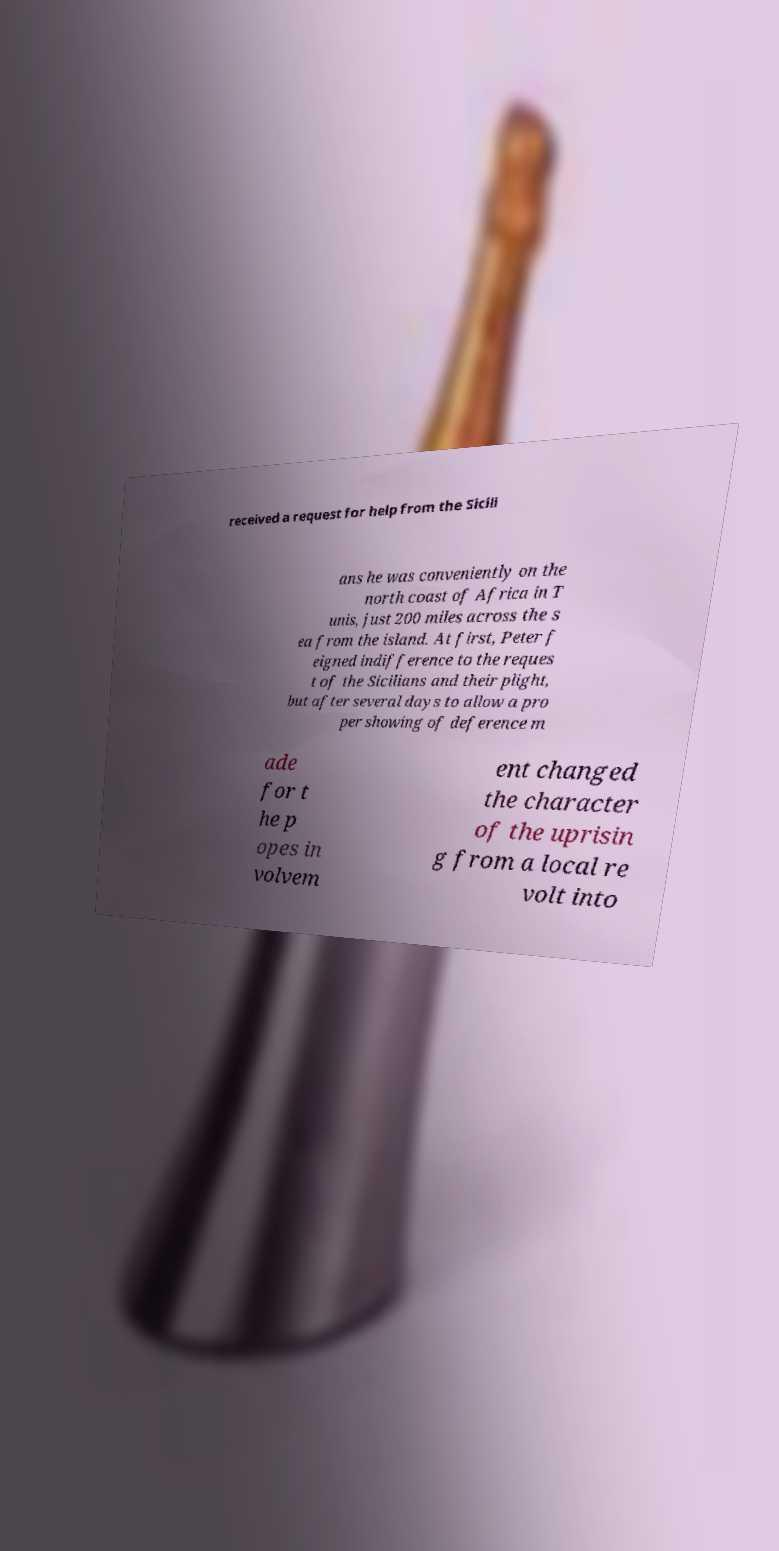I need the written content from this picture converted into text. Can you do that? received a request for help from the Sicili ans he was conveniently on the north coast of Africa in T unis, just 200 miles across the s ea from the island. At first, Peter f eigned indifference to the reques t of the Sicilians and their plight, but after several days to allow a pro per showing of deference m ade for t he p opes in volvem ent changed the character of the uprisin g from a local re volt into 